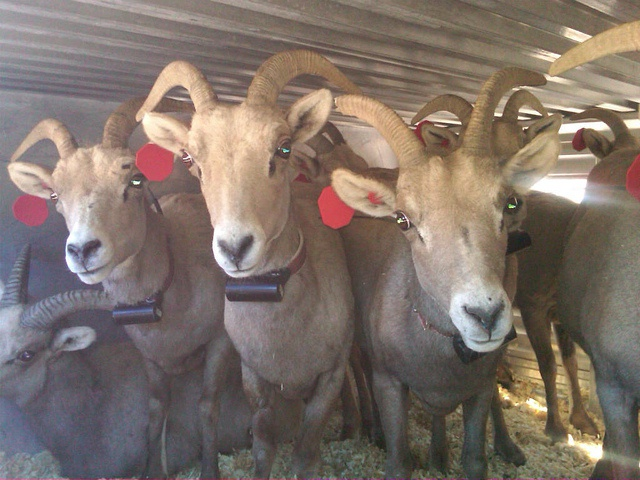Describe the objects in this image and their specific colors. I can see sheep in darkgray, gray, and tan tones, sheep in darkgray, gray, and tan tones, sheep in darkgray, gray, and tan tones, sheep in darkgray, gray, and black tones, and sheep in darkgray and gray tones in this image. 